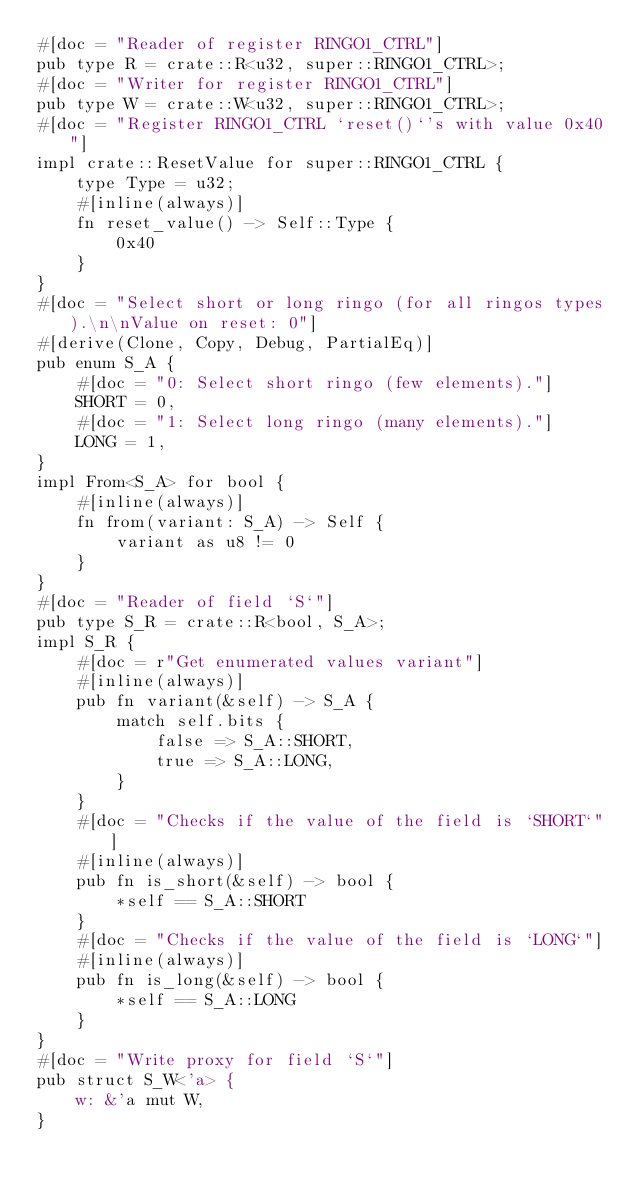<code> <loc_0><loc_0><loc_500><loc_500><_Rust_>#[doc = "Reader of register RINGO1_CTRL"]
pub type R = crate::R<u32, super::RINGO1_CTRL>;
#[doc = "Writer for register RINGO1_CTRL"]
pub type W = crate::W<u32, super::RINGO1_CTRL>;
#[doc = "Register RINGO1_CTRL `reset()`'s with value 0x40"]
impl crate::ResetValue for super::RINGO1_CTRL {
    type Type = u32;
    #[inline(always)]
    fn reset_value() -> Self::Type {
        0x40
    }
}
#[doc = "Select short or long ringo (for all ringos types).\n\nValue on reset: 0"]
#[derive(Clone, Copy, Debug, PartialEq)]
pub enum S_A {
    #[doc = "0: Select short ringo (few elements)."]
    SHORT = 0,
    #[doc = "1: Select long ringo (many elements)."]
    LONG = 1,
}
impl From<S_A> for bool {
    #[inline(always)]
    fn from(variant: S_A) -> Self {
        variant as u8 != 0
    }
}
#[doc = "Reader of field `S`"]
pub type S_R = crate::R<bool, S_A>;
impl S_R {
    #[doc = r"Get enumerated values variant"]
    #[inline(always)]
    pub fn variant(&self) -> S_A {
        match self.bits {
            false => S_A::SHORT,
            true => S_A::LONG,
        }
    }
    #[doc = "Checks if the value of the field is `SHORT`"]
    #[inline(always)]
    pub fn is_short(&self) -> bool {
        *self == S_A::SHORT
    }
    #[doc = "Checks if the value of the field is `LONG`"]
    #[inline(always)]
    pub fn is_long(&self) -> bool {
        *self == S_A::LONG
    }
}
#[doc = "Write proxy for field `S`"]
pub struct S_W<'a> {
    w: &'a mut W,
}</code> 